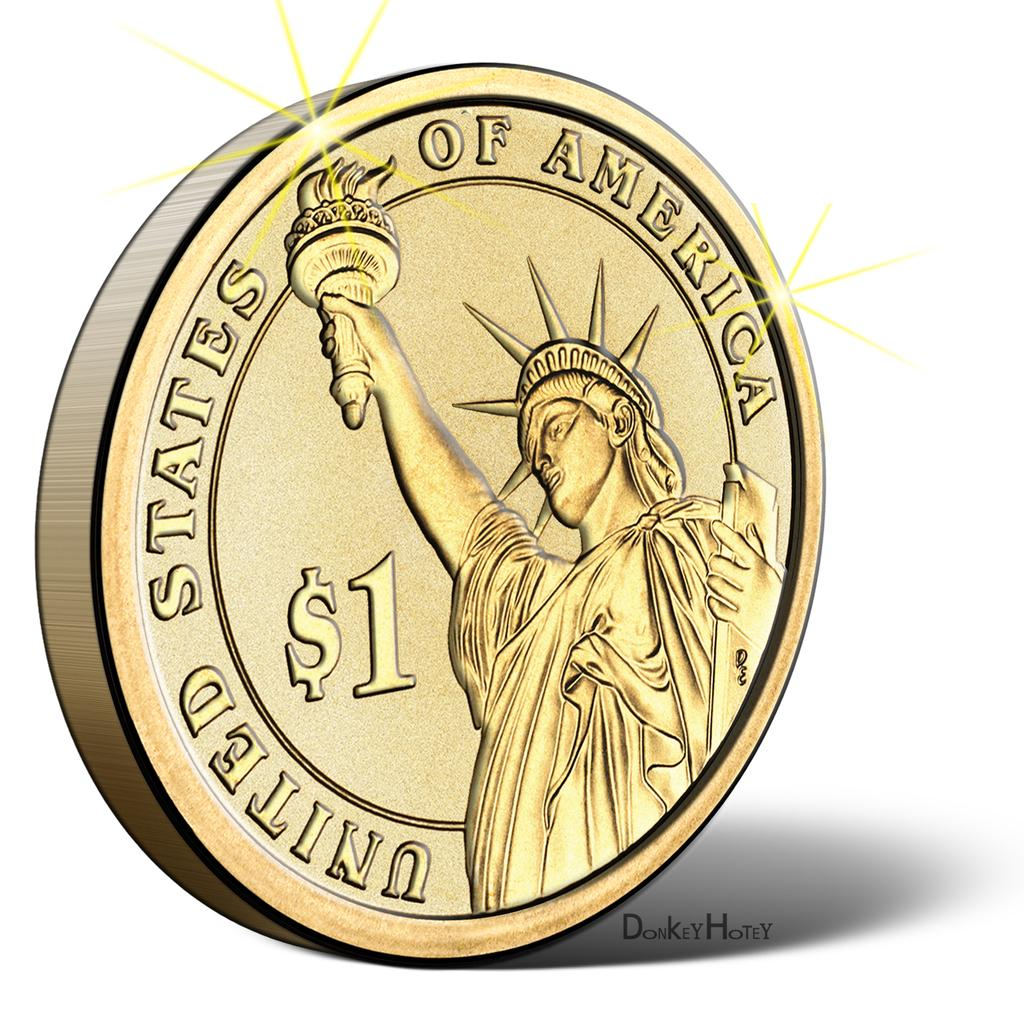What is the main subject of the image? The main subject of the image is an animated picture of a coin. Can you describe the animation of the coin in the image? Unfortunately, the facts provided do not give any details about the animation of the coin. What is the context or theme of the image? The context or theme of the theme of the image cannot be determined from the provided fact. What type of plough is being used in the image? There is no plough present in the image; it contains an animated picture of a coin. What type of trade is being depicted in the image? There is no trade being depicted in the image; it contains an animated picture of a coin. 